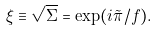<formula> <loc_0><loc_0><loc_500><loc_500>\xi \equiv \sqrt { \Sigma } = \exp ( i \tilde { \pi } / f ) .</formula> 